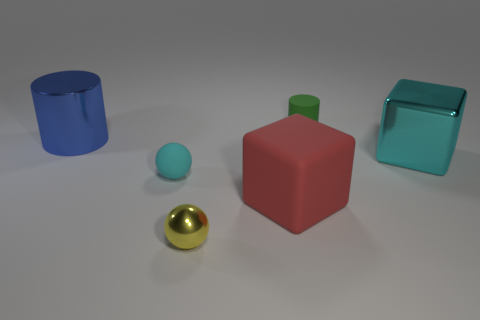What is the size of the ball that is the same color as the metallic cube?
Provide a short and direct response. Small. Are there the same number of large matte objects to the left of the yellow shiny sphere and gray rubber objects?
Make the answer very short. Yes. There is another object that is the same shape as the cyan matte object; what color is it?
Provide a succinct answer. Yellow. Is the cylinder that is on the left side of the tiny green matte thing made of the same material as the green cylinder?
Provide a short and direct response. No. What number of tiny objects are either blue metallic cylinders or brown matte things?
Your response must be concise. 0. What size is the cyan sphere?
Your answer should be very brief. Small. There is a green rubber cylinder; is it the same size as the cylinder that is left of the small green matte cylinder?
Make the answer very short. No. What number of yellow things are either small spheres or large metal cylinders?
Provide a succinct answer. 1. What number of big things are there?
Your answer should be compact. 3. There is a shiny thing in front of the large cyan metallic object; how big is it?
Offer a terse response. Small. 